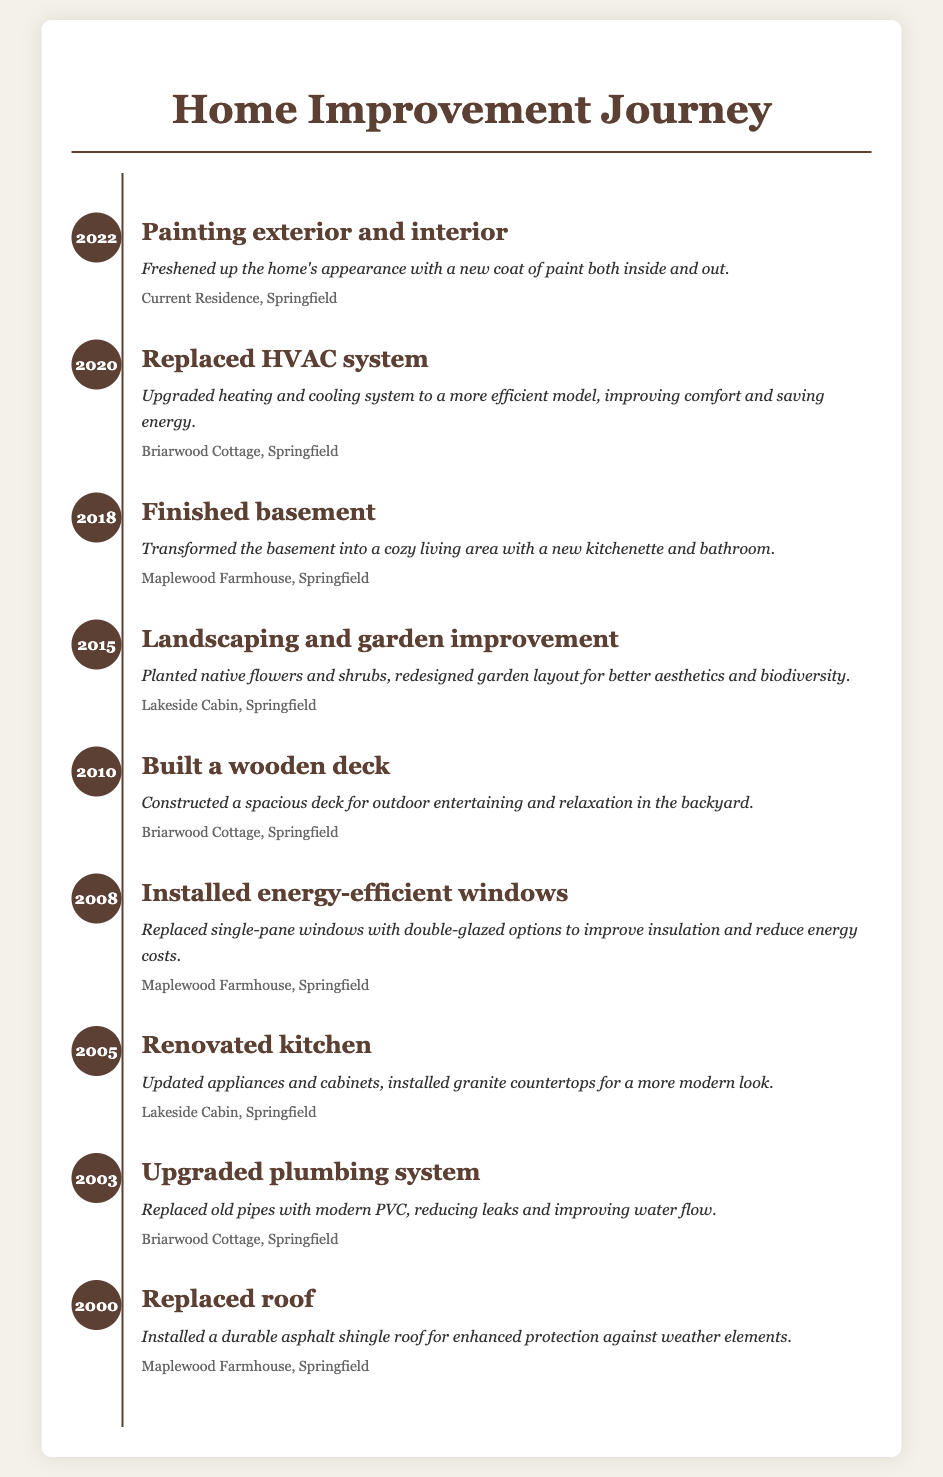What year was the kitchen renovated? The document states that the kitchen was renovated in 2005.
Answer: 2005 What was replaced in 2020? The entry for 2020 mentions that the HVAC system was replaced.
Answer: HVAC system Where is the current residence located? The document indicates the current residence is in Springfield.
Answer: Springfield What significant upgrade was made in 2010? In 2010, the document states that a wooden deck was built.
Answer: Wooden deck How many home maintenance tasks are listed? The document lists a total of 9 home maintenance tasks across the years.
Answer: 9 What type of windows were installed in 2008? The document describes the installation of energy-efficient windows in 2008.
Answer: Energy-efficient windows What did the renovation in 2005 update? The renovation in 2005 updated appliances and cabinets in the kitchen.
Answer: Appliances and cabinets What year did landscaping and garden improvement occur? The document specifies that landscaping and garden improvement took place in 2015.
Answer: 2015 Which residence had the basement finished? The basement was finished in the Maplewood Farmhouse according to the document.
Answer: Maplewood Farmhouse 